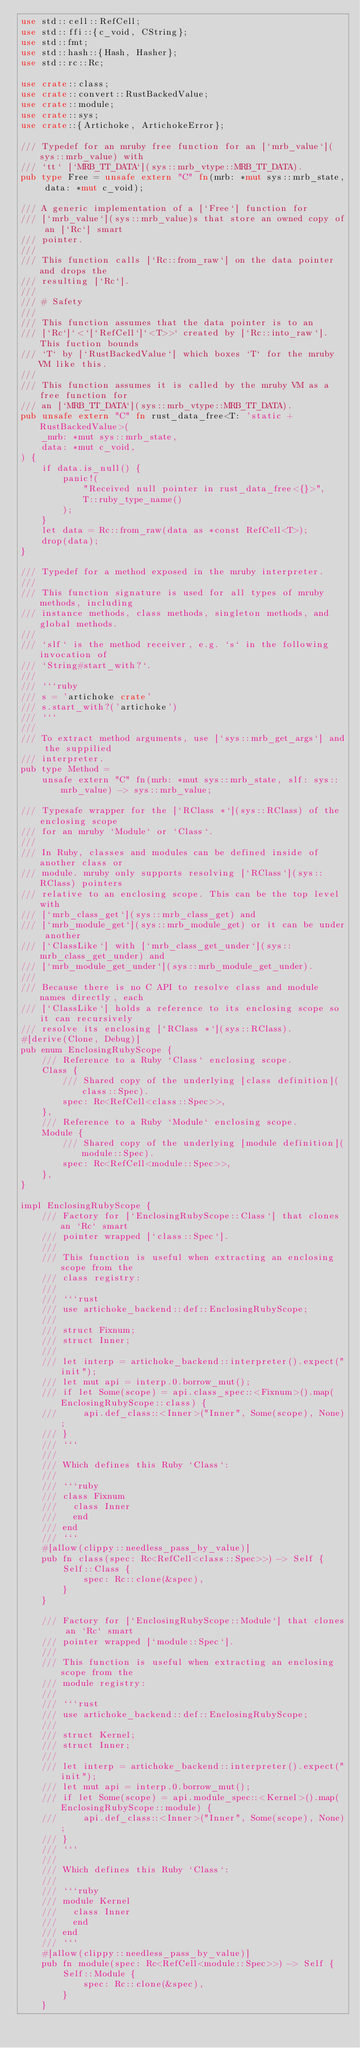<code> <loc_0><loc_0><loc_500><loc_500><_Rust_>use std::cell::RefCell;
use std::ffi::{c_void, CString};
use std::fmt;
use std::hash::{Hash, Hasher};
use std::rc::Rc;

use crate::class;
use crate::convert::RustBackedValue;
use crate::module;
use crate::sys;
use crate::{Artichoke, ArtichokeError};

/// Typedef for an mruby free function for an [`mrb_value`](sys::mrb_value) with
/// `tt` [`MRB_TT_DATA`](sys::mrb_vtype::MRB_TT_DATA).
pub type Free = unsafe extern "C" fn(mrb: *mut sys::mrb_state, data: *mut c_void);

/// A generic implementation of a [`Free`] function for
/// [`mrb_value`](sys::mrb_value)s that store an owned copy of an [`Rc`] smart
/// pointer.
///
/// This function calls [`Rc::from_raw`] on the data pointer and drops the
/// resulting [`Rc`].
///
/// # Safety
///
/// This function assumes that the data pointer is to an
/// [`Rc`]`<`[`RefCell`]`<T>>` created by [`Rc::into_raw`]. This fuction bounds
/// `T` by [`RustBackedValue`] which boxes `T` for the mruby VM like this.
///
/// This function assumes it is called by the mruby VM as a free function for
/// an [`MRB_TT_DATA`](sys::mrb_vtype::MRB_TT_DATA).
pub unsafe extern "C" fn rust_data_free<T: 'static + RustBackedValue>(
    _mrb: *mut sys::mrb_state,
    data: *mut c_void,
) {
    if data.is_null() {
        panic!(
            "Received null pointer in rust_data_free<{}>",
            T::ruby_type_name()
        );
    }
    let data = Rc::from_raw(data as *const RefCell<T>);
    drop(data);
}

/// Typedef for a method exposed in the mruby interpreter.
///
/// This function signature is used for all types of mruby methods, including
/// instance methods, class methods, singleton methods, and global methods.
///
/// `slf` is the method receiver, e.g. `s` in the following invocation of
/// `String#start_with?`.
///
/// ```ruby
/// s = 'artichoke crate'
/// s.start_with?('artichoke')
/// ```
///
/// To extract method arguments, use [`sys::mrb_get_args`] and the suppilied
/// interpreter.
pub type Method =
    unsafe extern "C" fn(mrb: *mut sys::mrb_state, slf: sys::mrb_value) -> sys::mrb_value;

/// Typesafe wrapper for the [`RClass *`](sys::RClass) of the enclosing scope
/// for an mruby `Module` or `Class`.
///
/// In Ruby, classes and modules can be defined inside of another class or
/// module. mruby only supports resolving [`RClass`](sys::RClass) pointers
/// relative to an enclosing scope. This can be the top level with
/// [`mrb_class_get`](sys::mrb_class_get) and
/// [`mrb_module_get`](sys::mrb_module_get) or it can be under another
/// [`ClassLike`] with [`mrb_class_get_under`](sys::mrb_class_get_under) and
/// [`mrb_module_get_under`](sys::mrb_module_get_under).
///
/// Because there is no C API to resolve class and module names directly, each
/// [`ClassLike`] holds a reference to its enclosing scope so it can recursively
/// resolve its enclosing [`RClass *`](sys::RClass).
#[derive(Clone, Debug)]
pub enum EnclosingRubyScope {
    /// Reference to a Ruby `Class` enclosing scope.
    Class {
        /// Shared copy of the underlying [class definition](class::Spec).
        spec: Rc<RefCell<class::Spec>>,
    },
    /// Reference to a Ruby `Module` enclosing scope.
    Module {
        /// Shared copy of the underlying [module definition](module::Spec).
        spec: Rc<RefCell<module::Spec>>,
    },
}

impl EnclosingRubyScope {
    /// Factory for [`EnclosingRubyScope::Class`] that clones an `Rc` smart
    /// pointer wrapped [`class::Spec`].
    ///
    /// This function is useful when extracting an enclosing scope from the
    /// class registry:
    ///
    /// ```rust
    /// use artichoke_backend::def::EnclosingRubyScope;
    ///
    /// struct Fixnum;
    /// struct Inner;
    ///
    /// let interp = artichoke_backend::interpreter().expect("init");
    /// let mut api = interp.0.borrow_mut();
    /// if let Some(scope) = api.class_spec::<Fixnum>().map(EnclosingRubyScope::class) {
    ///     api.def_class::<Inner>("Inner", Some(scope), None);
    /// }
    /// ```
    ///
    /// Which defines this Ruby `Class`:
    ///
    /// ```ruby
    /// class Fixnum
    ///   class Inner
    ///   end
    /// end
    /// ```
    #[allow(clippy::needless_pass_by_value)]
    pub fn class(spec: Rc<RefCell<class::Spec>>) -> Self {
        Self::Class {
            spec: Rc::clone(&spec),
        }
    }

    /// Factory for [`EnclosingRubyScope::Module`] that clones an `Rc` smart
    /// pointer wrapped [`module::Spec`].
    ///
    /// This function is useful when extracting an enclosing scope from the
    /// module registry:
    ///
    /// ```rust
    /// use artichoke_backend::def::EnclosingRubyScope;
    ///
    /// struct Kernel;
    /// struct Inner;
    ///
    /// let interp = artichoke_backend::interpreter().expect("init");
    /// let mut api = interp.0.borrow_mut();
    /// if let Some(scope) = api.module_spec::<Kernel>().map(EnclosingRubyScope::module) {
    ///     api.def_class::<Inner>("Inner", Some(scope), None);
    /// }
    /// ```
    ///
    /// Which defines this Ruby `Class`:
    ///
    /// ```ruby
    /// module Kernel
    ///   class Inner
    ///   end
    /// end
    /// ```
    #[allow(clippy::needless_pass_by_value)]
    pub fn module(spec: Rc<RefCell<module::Spec>>) -> Self {
        Self::Module {
            spec: Rc::clone(&spec),
        }
    }
</code> 